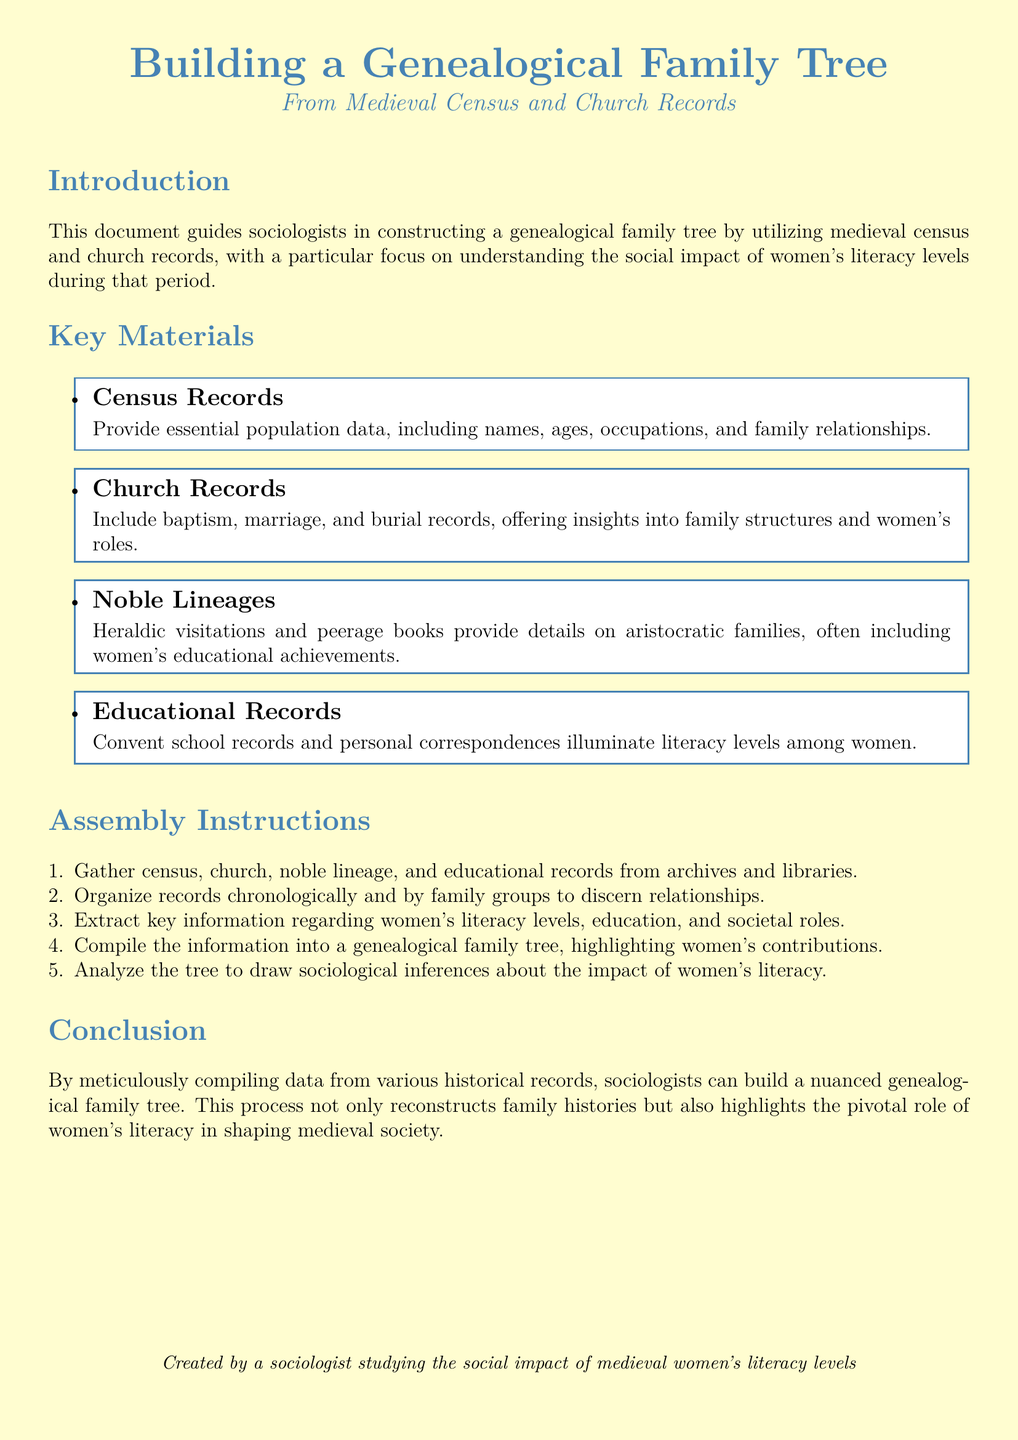What is the main focus of the document? The document primarily focuses on constructing a genealogical family tree by utilizing medieval census and church records, emphasizing women's literacy levels.
Answer: women's literacy levels What type of records are emphasized for building the family tree? The document highlights several types of records that are essential for building the genealogical family tree, indicating their importance.
Answer: census and church records How many key materials are listed in the document? The document explicitly enumerates the materials needed for the assembly, which provides insight into its structure.
Answer: four What is the first step in the assembly instructions? The assembly instructions outline a systematic approach, with the first step clearly identified for the reader's benefit.
Answer: Gather records Which records provide insights into women's roles? The document specifies particular records that offer valuable information regarding women's contribution and societal position.
Answer: Church Records What type of analysis is suggested at the end of the instructions? The document indicates that after compiling the family tree, a specific kind of analysis is recommended to draw conclusions.
Answer: sociological inferences What is the background of the document creator? The last line provides insight into the creator's profession and focus area, reflecting their expertise and purpose for writing the document.
Answer: sociologist What aspect of society does the document aim to highlight through research? The document is not only about constructing trees but also aims to underscore a key societal element through the research process.
Answer: women's literacy 